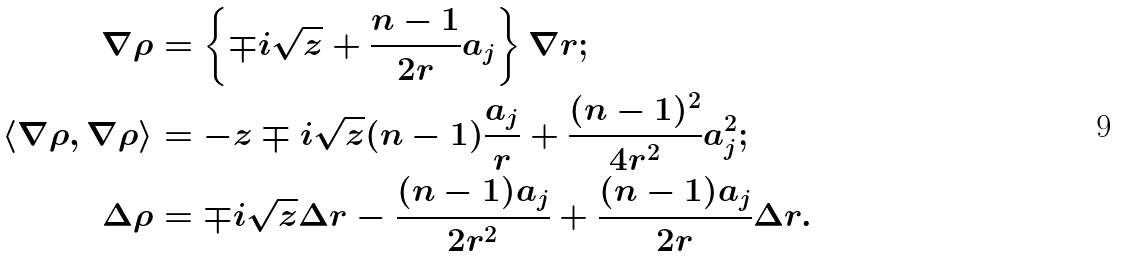<formula> <loc_0><loc_0><loc_500><loc_500>\nabla \rho & = \left \{ \mp i \sqrt { z } + \frac { n - 1 } { 2 r } a _ { j } \right \} \nabla r ; \\ \langle \nabla \rho , \nabla \rho \rangle & = - z \mp i \sqrt { z } ( n - 1 ) \frac { a _ { j } } { r } + \frac { ( n - 1 ) ^ { 2 } } { 4 r ^ { 2 } } a _ { j } ^ { 2 } ; \\ \Delta \rho & = \mp i \sqrt { z } \Delta r - \frac { ( n - 1 ) a _ { j } } { 2 r ^ { 2 } } + \frac { ( n - 1 ) a _ { j } } { 2 r } \Delta r .</formula> 